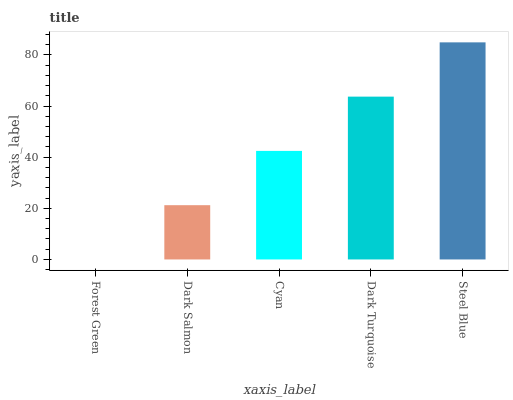Is Forest Green the minimum?
Answer yes or no. Yes. Is Steel Blue the maximum?
Answer yes or no. Yes. Is Dark Salmon the minimum?
Answer yes or no. No. Is Dark Salmon the maximum?
Answer yes or no. No. Is Dark Salmon greater than Forest Green?
Answer yes or no. Yes. Is Forest Green less than Dark Salmon?
Answer yes or no. Yes. Is Forest Green greater than Dark Salmon?
Answer yes or no. No. Is Dark Salmon less than Forest Green?
Answer yes or no. No. Is Cyan the high median?
Answer yes or no. Yes. Is Cyan the low median?
Answer yes or no. Yes. Is Forest Green the high median?
Answer yes or no. No. Is Dark Turquoise the low median?
Answer yes or no. No. 